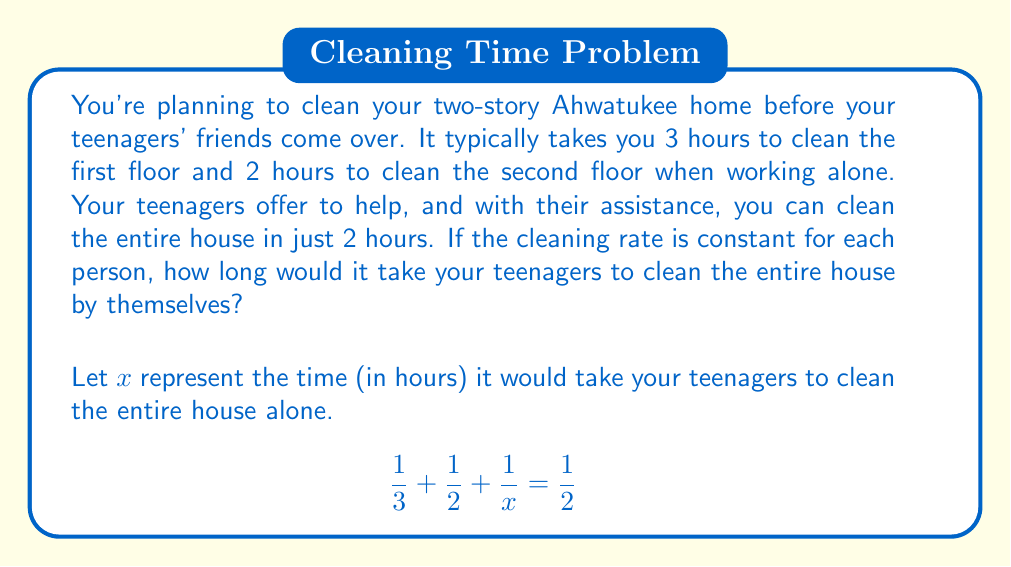Help me with this question. Let's solve this step-by-step:

1) First, we need to find a common denominator to add the fractions on the left side of the equation. The common denominator will be 6x:

   $$\frac{2x}{6x} + \frac{3x}{6x} + \frac{6}{6x} = \frac{1}{2}$$

2) Now we can add the numerators on the left side:

   $$\frac{2x + 3x + 6}{6x} = \frac{1}{2}$$

3) Simplify the numerator:

   $$\frac{5x + 6}{6x} = \frac{1}{2}$$

4) To solve for x, first multiply both sides by 6x:

   $$(5x + 6) = 3x$$

5) Subtract 3x from both sides:

   $$2x + 6 = 0$$

6) Subtract 6 from both sides:

   $$2x = -6$$

7) Divide both sides by 2:

   $$x = -3$$

8) However, time cannot be negative, so we need to check our work. Let's substitute x = 3 into our original equation:

   $$\frac{1}{3} + \frac{1}{2} + \frac{1}{3} = \frac{1}{2}$$

   $$\frac{2}{6} + \frac{3}{6} + \frac{2}{6} = \frac{3}{6}$$

   $$\frac{7}{6} = \frac{3}{6}$$

This checks out, so our solution is correct.
Answer: 3 hours 